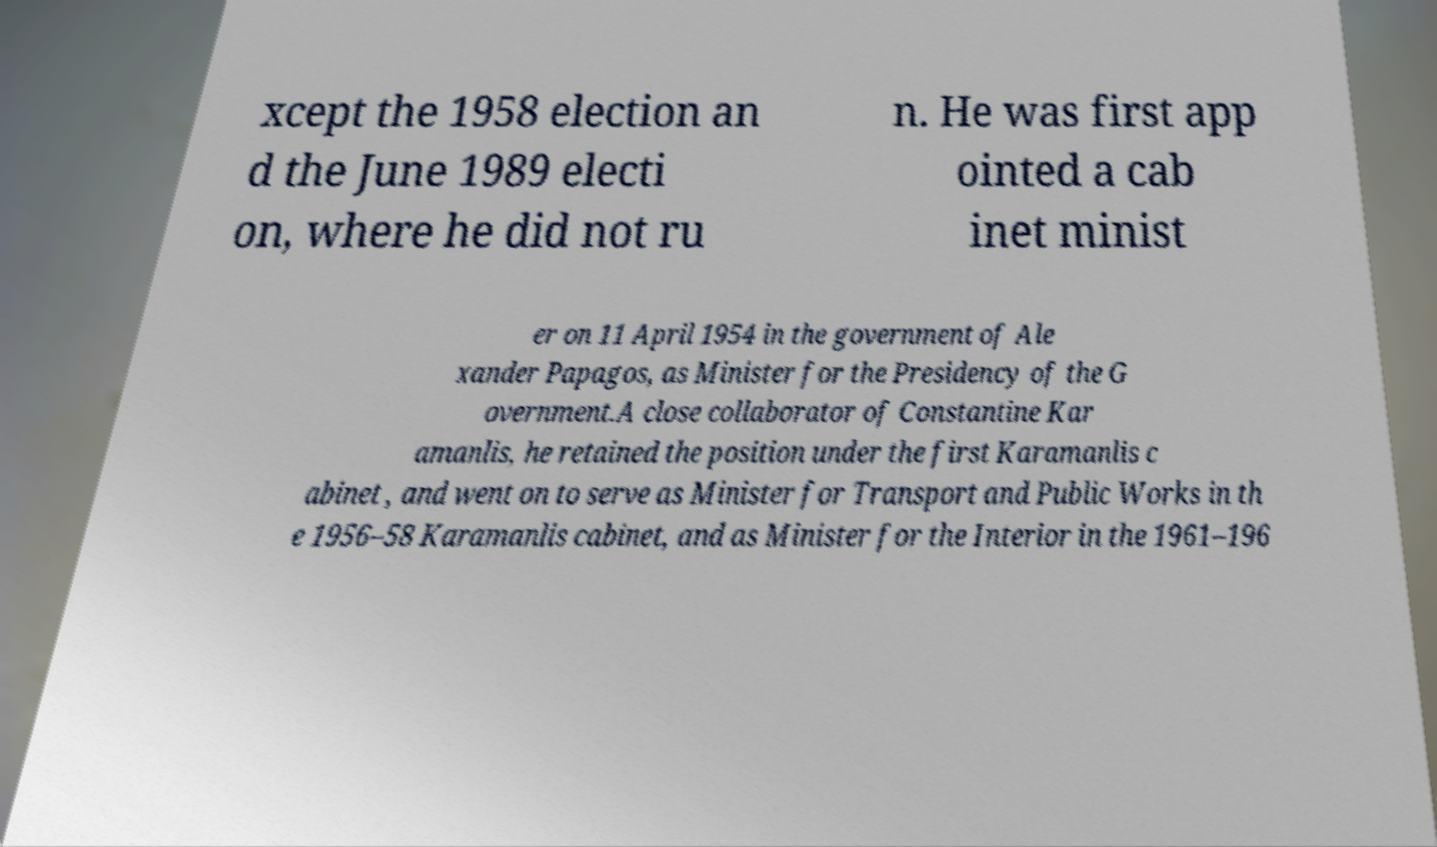Please identify and transcribe the text found in this image. xcept the 1958 election an d the June 1989 electi on, where he did not ru n. He was first app ointed a cab inet minist er on 11 April 1954 in the government of Ale xander Papagos, as Minister for the Presidency of the G overnment.A close collaborator of Constantine Kar amanlis, he retained the position under the first Karamanlis c abinet , and went on to serve as Minister for Transport and Public Works in th e 1956–58 Karamanlis cabinet, and as Minister for the Interior in the 1961–196 